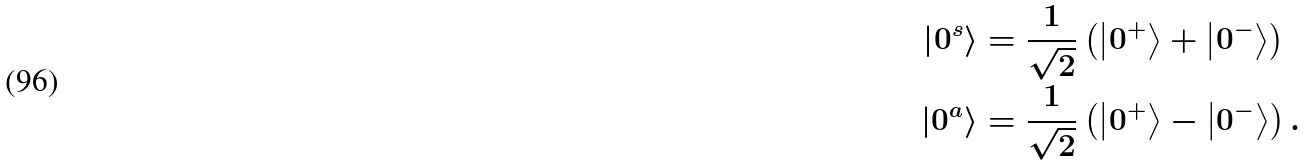Convert formula to latex. <formula><loc_0><loc_0><loc_500><loc_500>\left | 0 ^ { s } \right \rangle & = \frac { 1 } { \sqrt { 2 } } \left ( \left | 0 ^ { + } \right \rangle + \left | 0 ^ { - } \right \rangle \right ) \\ \left | 0 ^ { a } \right \rangle & = \frac { 1 } { \sqrt { 2 } } \left ( \left | 0 ^ { + } \right \rangle - \left | 0 ^ { - } \right \rangle \right ) .</formula> 